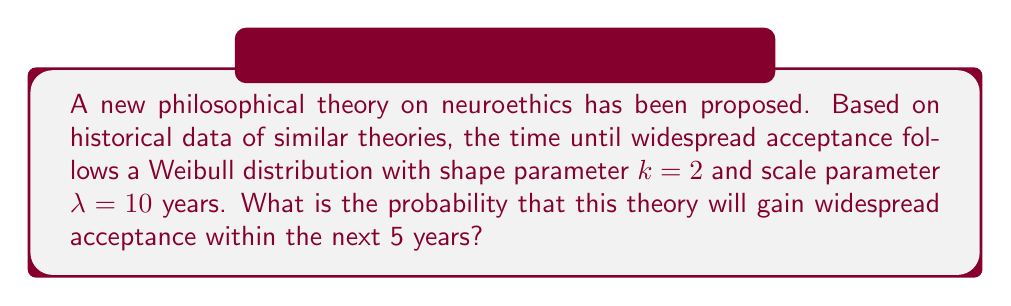Help me with this question. To solve this problem, we'll use survival analysis and the concept of hazard functions. The Weibull distribution is commonly used in survival analysis.

Step 1: Recall the survival function for a Weibull distribution:
$$S(t) = e^{-(\frac{t}{\lambda})^k}$$

Step 2: We want to find the probability of the event occurring within 5 years, which is the complement of the survival function:
$$P(T \leq 5) = 1 - S(5)$$

Step 3: Substitute the given values ($k=2$, $\lambda=10$, $t=5$) into the survival function:
$$S(5) = e^{-(\frac{5}{10})^2}$$

Step 4: Simplify the expression:
$$S(5) = e^{-(\frac{1}{4})} = e^{-0.25}$$

Step 5: Calculate the value:
$$S(5) \approx 0.7788$$

Step 6: Calculate the probability of the event occurring within 5 years:
$$P(T \leq 5) = 1 - S(5) = 1 - 0.7788 \approx 0.2212$$

Therefore, the probability that the theory will gain widespread acceptance within the next 5 years is approximately 0.2212 or 22.12%.
Answer: 0.2212 